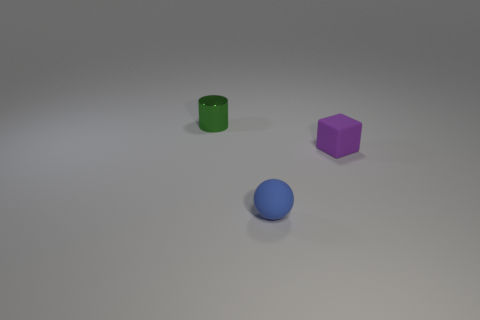Is the shape of the tiny object in front of the tiny purple object the same as the small thing to the right of the tiny blue matte thing?
Your answer should be very brief. No. Does the thing on the right side of the small blue ball have the same material as the small thing that is left of the small ball?
Provide a succinct answer. No. The thing behind the rubber thing that is behind the tiny ball is made of what material?
Make the answer very short. Metal. There is a object in front of the matte object behind the matte thing on the left side of the small purple matte object; what is its shape?
Keep it short and to the point. Sphere. How many tiny yellow cylinders are there?
Ensure brevity in your answer.  0. There is a small rubber object that is right of the blue matte sphere; what is its shape?
Give a very brief answer. Cube. There is a object to the left of the matte thing that is on the left side of the matte thing right of the blue ball; what is its color?
Provide a short and direct response. Green. There is a blue object that is the same material as the purple thing; what is its shape?
Give a very brief answer. Sphere. Are there fewer tiny rubber spheres than large green things?
Ensure brevity in your answer.  No. Does the block have the same material as the blue thing?
Your answer should be very brief. Yes. 